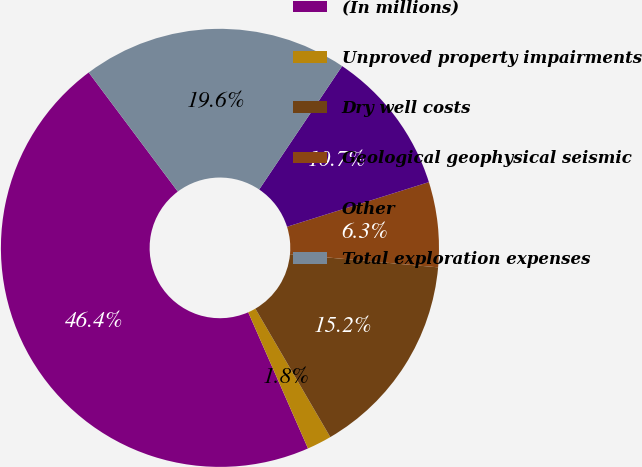<chart> <loc_0><loc_0><loc_500><loc_500><pie_chart><fcel>(In millions)<fcel>Unproved property impairments<fcel>Dry well costs<fcel>Geological geophysical seismic<fcel>Other<fcel>Total exploration expenses<nl><fcel>46.36%<fcel>1.82%<fcel>15.18%<fcel>6.27%<fcel>10.73%<fcel>19.64%<nl></chart> 